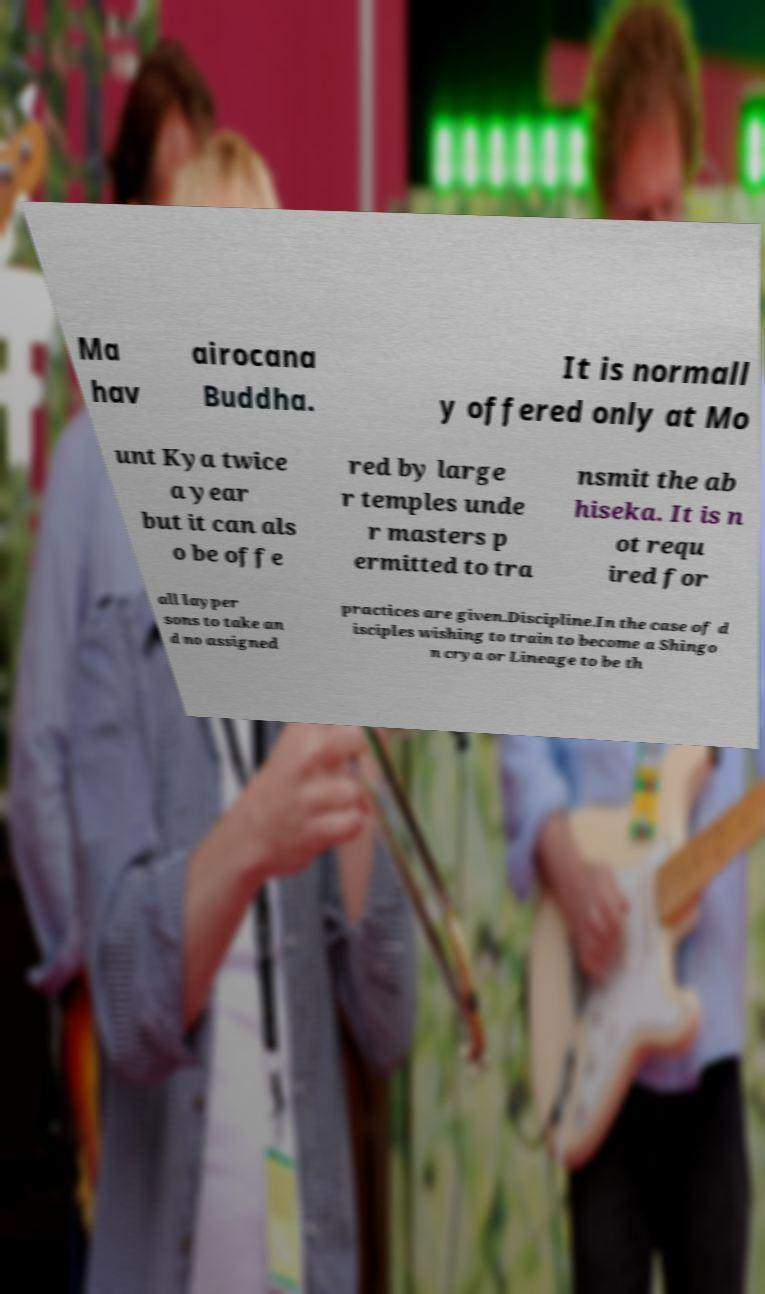Please identify and transcribe the text found in this image. Ma hav airocana Buddha. It is normall y offered only at Mo unt Kya twice a year but it can als o be offe red by large r temples unde r masters p ermitted to tra nsmit the ab hiseka. It is n ot requ ired for all layper sons to take an d no assigned practices are given.Discipline.In the case of d isciples wishing to train to become a Shingo n crya or Lineage to be th 